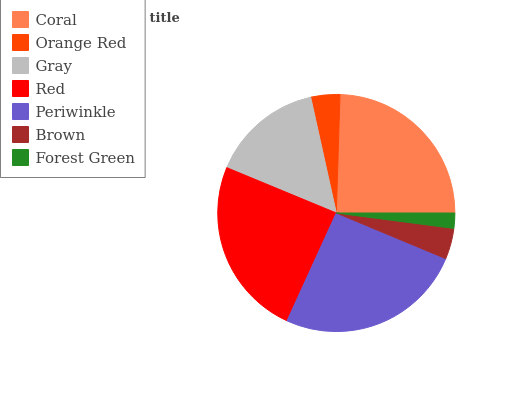Is Forest Green the minimum?
Answer yes or no. Yes. Is Periwinkle the maximum?
Answer yes or no. Yes. Is Orange Red the minimum?
Answer yes or no. No. Is Orange Red the maximum?
Answer yes or no. No. Is Coral greater than Orange Red?
Answer yes or no. Yes. Is Orange Red less than Coral?
Answer yes or no. Yes. Is Orange Red greater than Coral?
Answer yes or no. No. Is Coral less than Orange Red?
Answer yes or no. No. Is Gray the high median?
Answer yes or no. Yes. Is Gray the low median?
Answer yes or no. Yes. Is Red the high median?
Answer yes or no. No. Is Orange Red the low median?
Answer yes or no. No. 